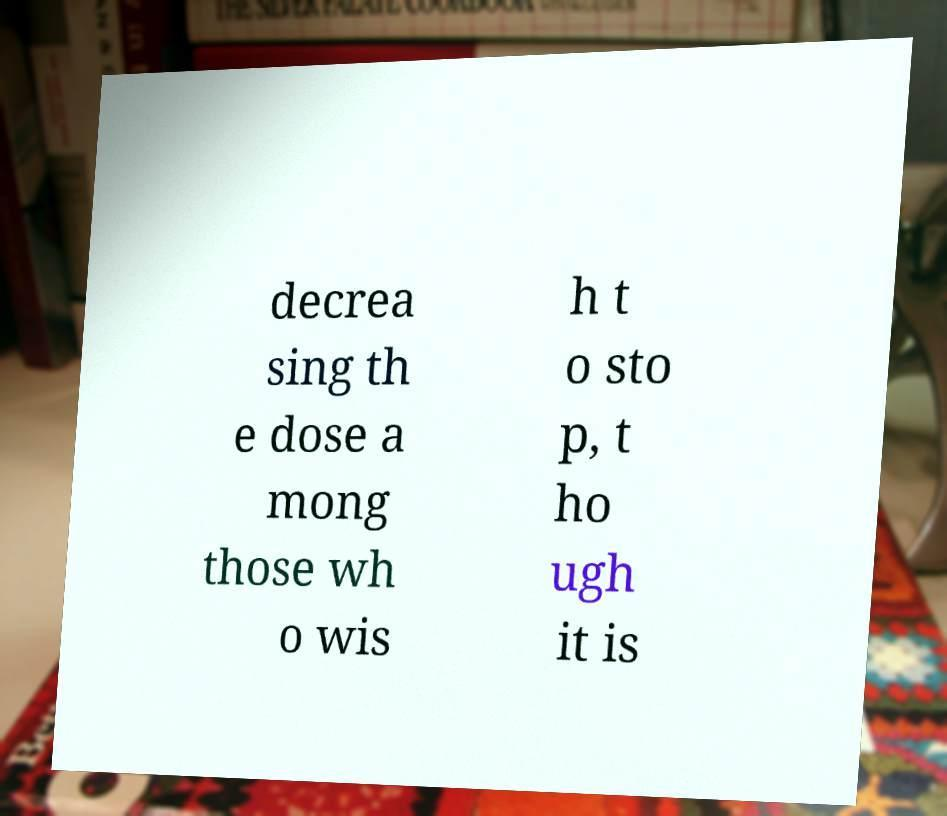Could you extract and type out the text from this image? decrea sing th e dose a mong those wh o wis h t o sto p, t ho ugh it is 